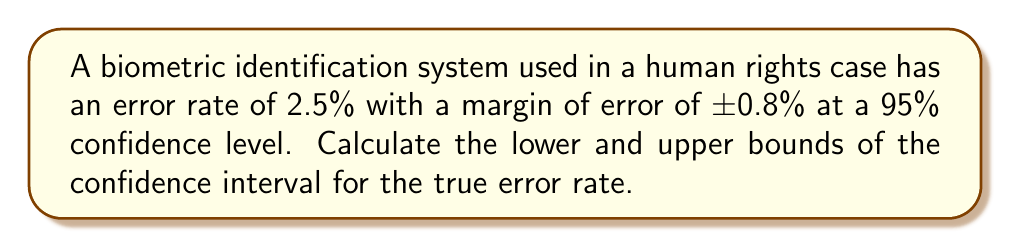Provide a solution to this math problem. To find the confidence interval, we need to follow these steps:

1. Identify the point estimate (sample statistic):
   The point estimate is the observed error rate, which is 2.5%.

2. Identify the margin of error:
   The margin of error is given as ±0.8%.

3. Calculate the lower bound of the confidence interval:
   Lower bound = Point estimate - Margin of error
   $$ \text{Lower bound} = 2.5\% - 0.8\% = 1.7\% $$

4. Calculate the upper bound of the confidence interval:
   Upper bound = Point estimate + Margin of error
   $$ \text{Upper bound} = 2.5\% + 0.8\% = 3.3\% $$

5. Express the confidence interval:
   The confidence interval is (Lower bound, Upper bound)
   $$ \text{Confidence Interval} = (1.7\%, 3.3\%) $$

This means we can be 95% confident that the true error rate of the biometric identification system falls between 1.7% and 3.3%.
Answer: (1.7%, 3.3%) 